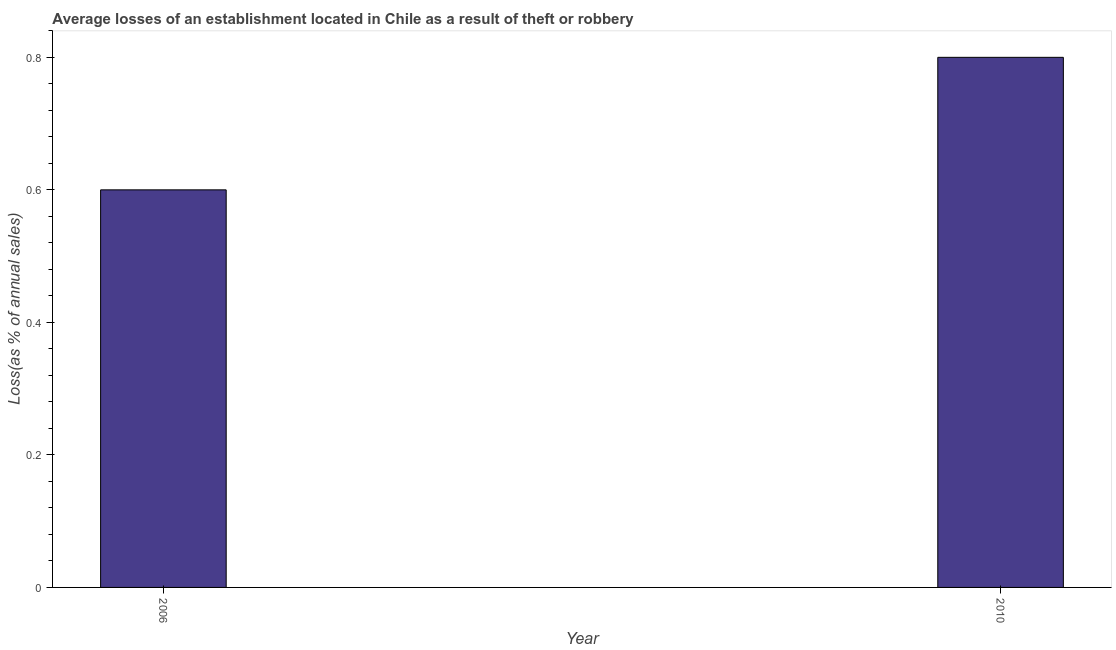Does the graph contain any zero values?
Offer a very short reply. No. Does the graph contain grids?
Ensure brevity in your answer.  No. What is the title of the graph?
Your response must be concise. Average losses of an establishment located in Chile as a result of theft or robbery. What is the label or title of the X-axis?
Keep it short and to the point. Year. What is the label or title of the Y-axis?
Your answer should be compact. Loss(as % of annual sales). Across all years, what is the maximum losses due to theft?
Provide a short and direct response. 0.8. Across all years, what is the minimum losses due to theft?
Provide a succinct answer. 0.6. In which year was the losses due to theft minimum?
Your answer should be compact. 2006. What is the sum of the losses due to theft?
Your answer should be compact. 1.4. What is the difference between the losses due to theft in 2006 and 2010?
Make the answer very short. -0.2. What is the average losses due to theft per year?
Your response must be concise. 0.7. What is the ratio of the losses due to theft in 2006 to that in 2010?
Keep it short and to the point. 0.75. Is the losses due to theft in 2006 less than that in 2010?
Make the answer very short. Yes. What is the difference between two consecutive major ticks on the Y-axis?
Ensure brevity in your answer.  0.2. What is the Loss(as % of annual sales) in 2006?
Ensure brevity in your answer.  0.6. What is the difference between the Loss(as % of annual sales) in 2006 and 2010?
Provide a short and direct response. -0.2. 